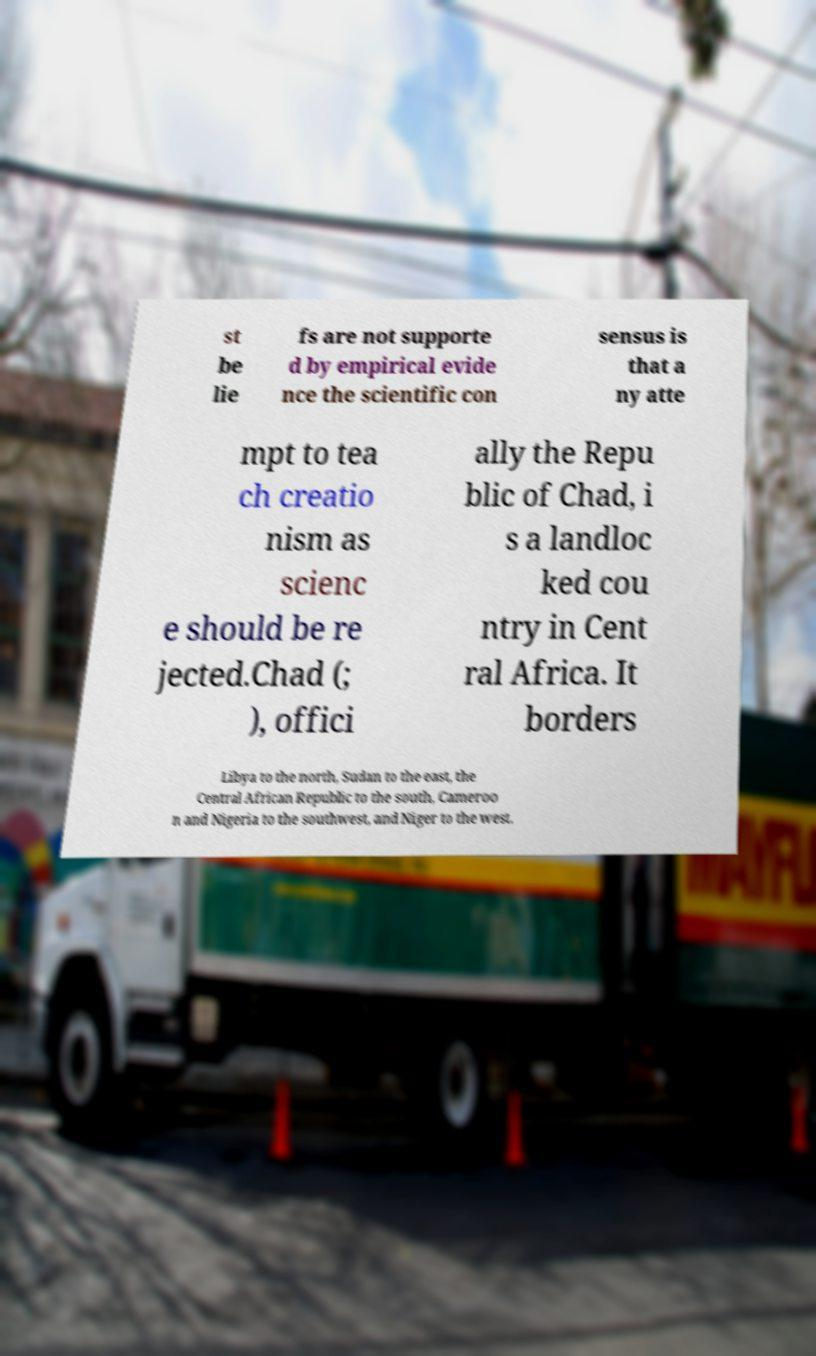Could you extract and type out the text from this image? st be lie fs are not supporte d by empirical evide nce the scientific con sensus is that a ny atte mpt to tea ch creatio nism as scienc e should be re jected.Chad (; ), offici ally the Repu blic of Chad, i s a landloc ked cou ntry in Cent ral Africa. It borders Libya to the north, Sudan to the east, the Central African Republic to the south, Cameroo n and Nigeria to the southwest, and Niger to the west. 